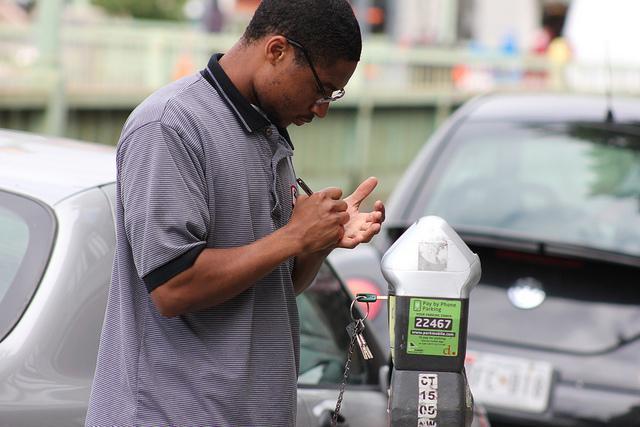How many cars are there?
Give a very brief answer. 2. 